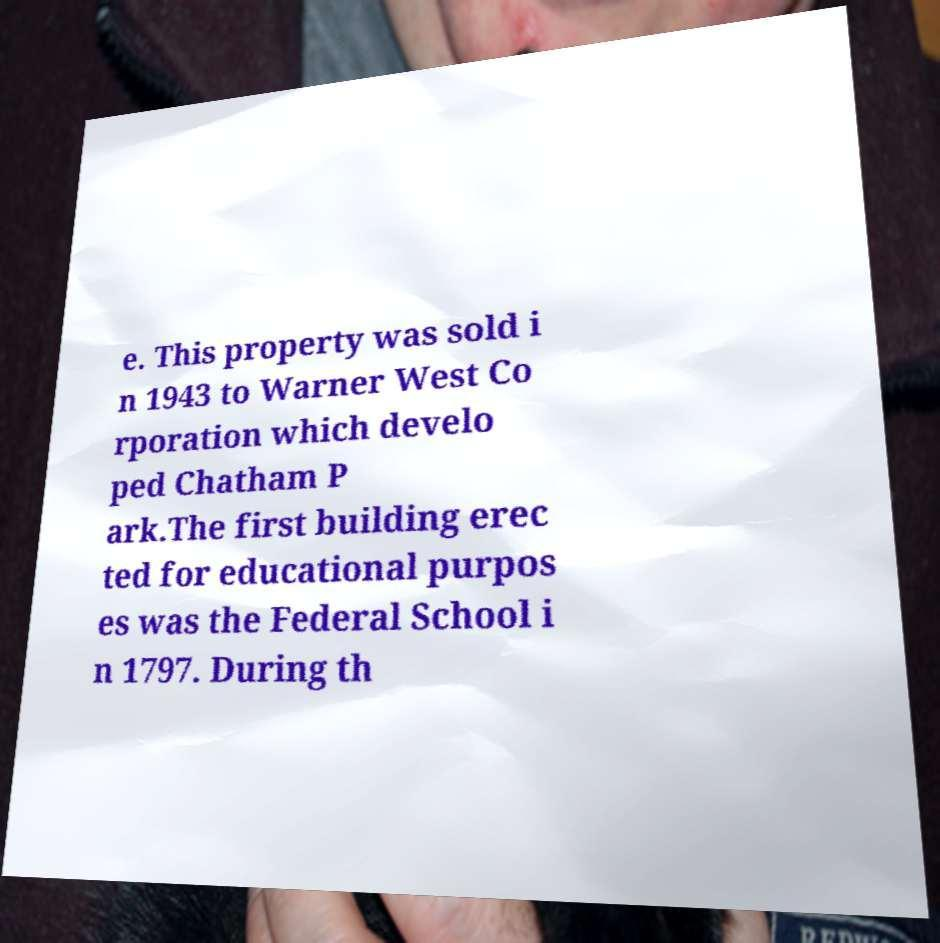Can you accurately transcribe the text from the provided image for me? e. This property was sold i n 1943 to Warner West Co rporation which develo ped Chatham P ark.The first building erec ted for educational purpos es was the Federal School i n 1797. During th 